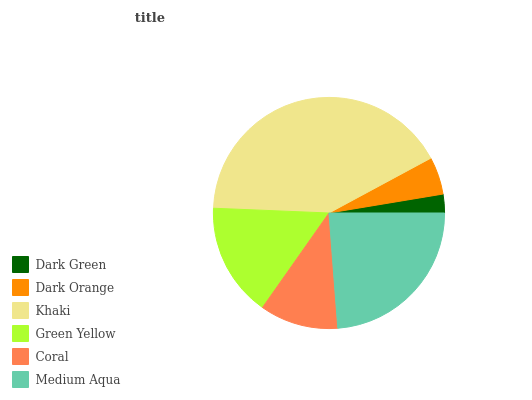Is Dark Green the minimum?
Answer yes or no. Yes. Is Khaki the maximum?
Answer yes or no. Yes. Is Dark Orange the minimum?
Answer yes or no. No. Is Dark Orange the maximum?
Answer yes or no. No. Is Dark Orange greater than Dark Green?
Answer yes or no. Yes. Is Dark Green less than Dark Orange?
Answer yes or no. Yes. Is Dark Green greater than Dark Orange?
Answer yes or no. No. Is Dark Orange less than Dark Green?
Answer yes or no. No. Is Green Yellow the high median?
Answer yes or no. Yes. Is Coral the low median?
Answer yes or no. Yes. Is Medium Aqua the high median?
Answer yes or no. No. Is Green Yellow the low median?
Answer yes or no. No. 